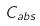Convert formula to latex. <formula><loc_0><loc_0><loc_500><loc_500>C _ { a b s }</formula> 